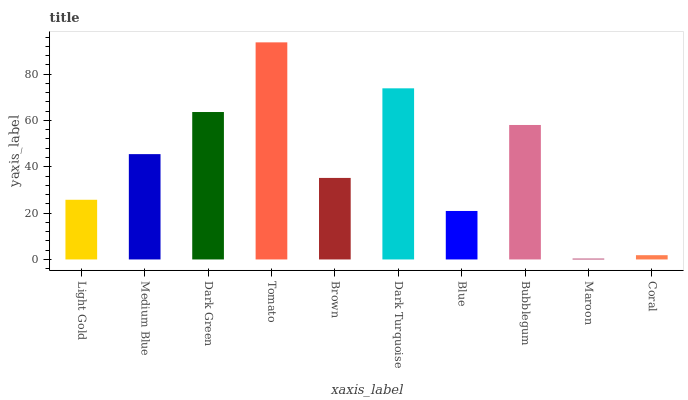Is Maroon the minimum?
Answer yes or no. Yes. Is Tomato the maximum?
Answer yes or no. Yes. Is Medium Blue the minimum?
Answer yes or no. No. Is Medium Blue the maximum?
Answer yes or no. No. Is Medium Blue greater than Light Gold?
Answer yes or no. Yes. Is Light Gold less than Medium Blue?
Answer yes or no. Yes. Is Light Gold greater than Medium Blue?
Answer yes or no. No. Is Medium Blue less than Light Gold?
Answer yes or no. No. Is Medium Blue the high median?
Answer yes or no. Yes. Is Brown the low median?
Answer yes or no. Yes. Is Coral the high median?
Answer yes or no. No. Is Light Gold the low median?
Answer yes or no. No. 